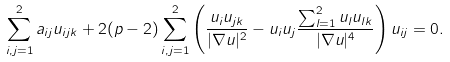Convert formula to latex. <formula><loc_0><loc_0><loc_500><loc_500>\sum _ { i , j = 1 } ^ { 2 } a _ { i j } u _ { i j k } + 2 ( p - 2 ) \sum _ { i , j = 1 } ^ { 2 } \left ( \frac { u _ { i } u _ { j k } } { | \nabla u | ^ { 2 } } - u _ { i } u _ { j } \frac { \sum _ { l = 1 } ^ { 2 } u _ { l } u _ { l k } } { | \nabla u | ^ { 4 } } \right ) u _ { i j } = 0 .</formula> 